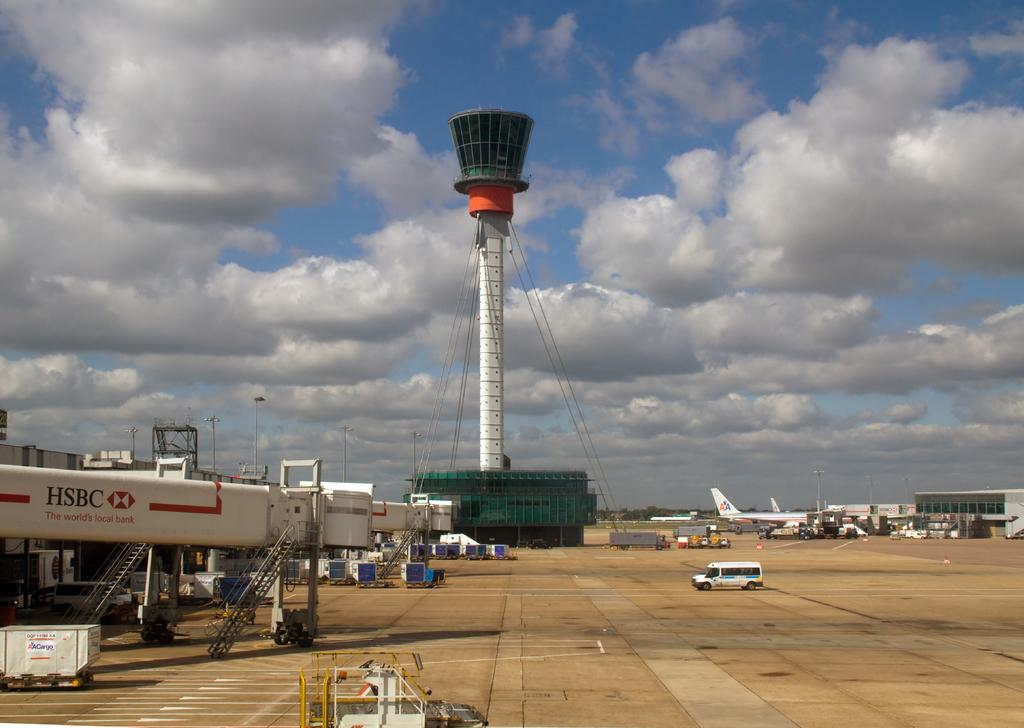<image>
Provide a brief description of the given image. HSBC bank is advertised near a radio control tower. 